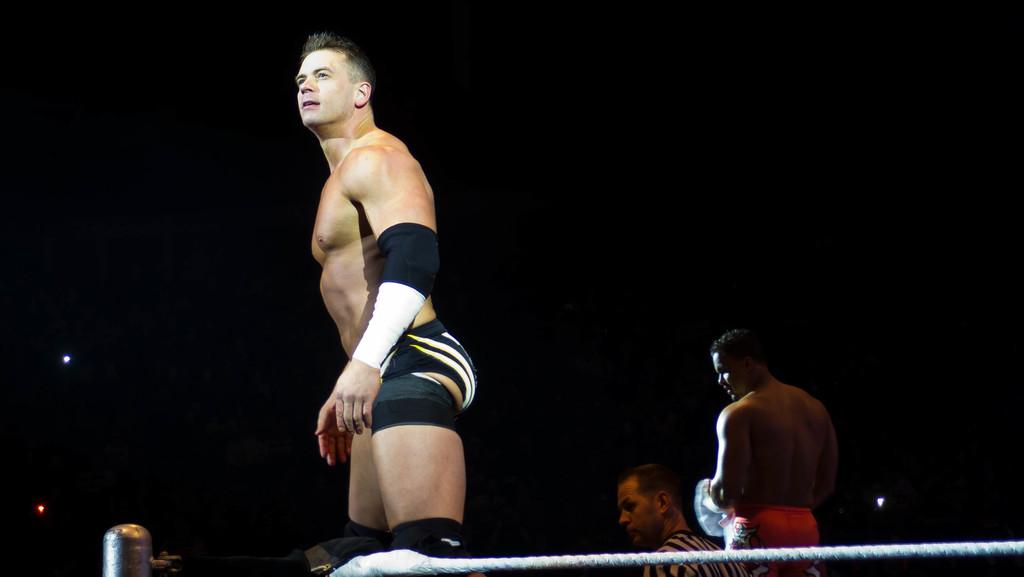What is the main subject of the image? The main subject of the image is a person standing. What is the person wearing that is visible in the image? The person is wearing a knee pad. What object can be seen in the image besides the person? There is a rope in the image. Are there any other people in the image? Yes, there are other people standing in the image. What can be observed about the background of the image? The background of the image is dark. What type of popcorn is being distributed to the people in the image? There is no popcorn present in the image, and therefore no distribution is taking place. What is the number of people in the image? The number of people in the image cannot be determined from the provided facts; we only know that there are other people standing in the image. 